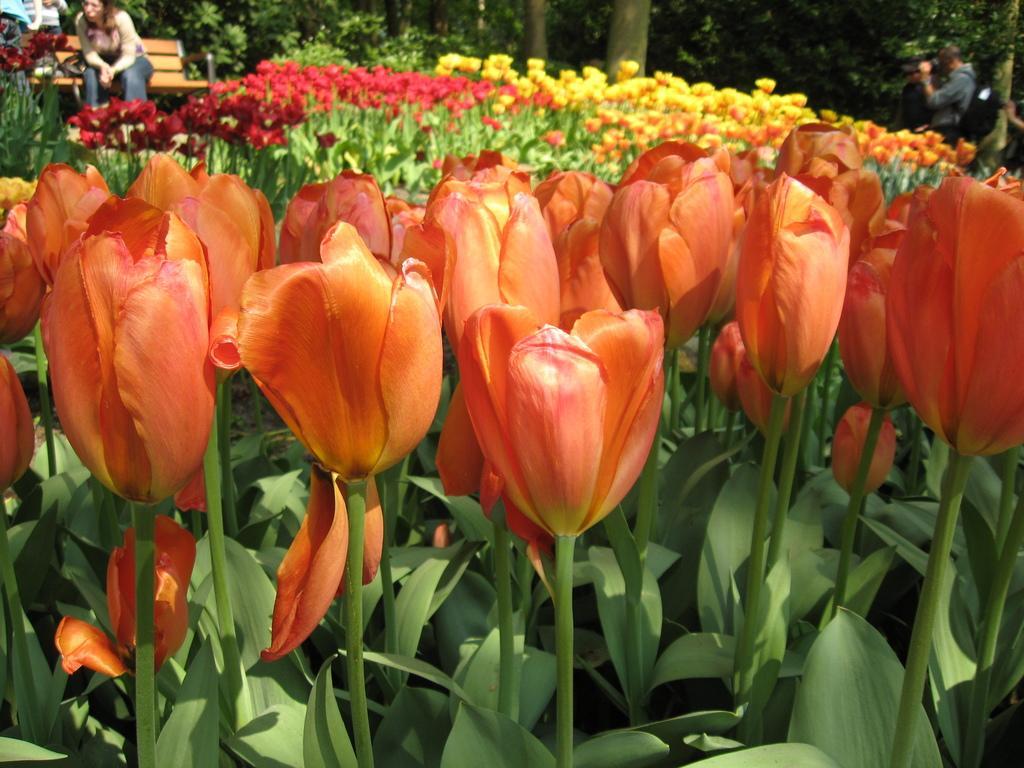Describe this image in one or two sentences. In this image I can see flowering plants, for persons, bench and trees. This image is taken may be in a garden during a day. 